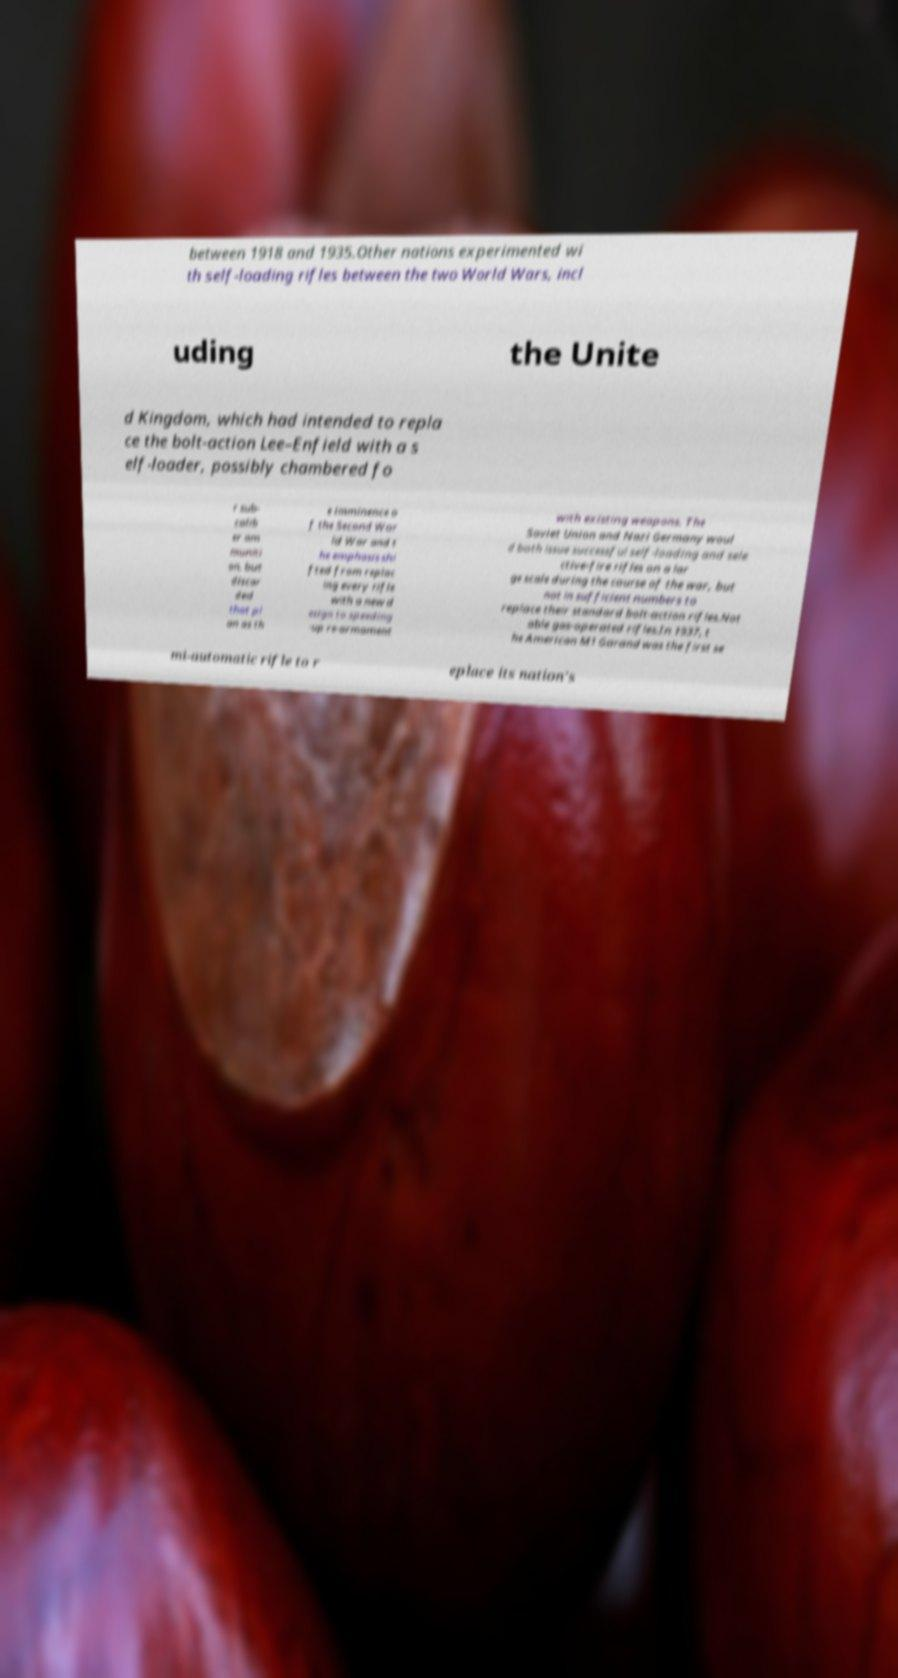Could you extract and type out the text from this image? between 1918 and 1935.Other nations experimented wi th self-loading rifles between the two World Wars, incl uding the Unite d Kingdom, which had intended to repla ce the bolt-action Lee–Enfield with a s elf-loader, possibly chambered fo r sub- calib er am muniti on, but discar ded that pl an as th e imminence o f the Second Wor ld War and t he emphasis shi fted from replac ing every rifle with a new d esign to speeding -up re-armament with existing weapons. The Soviet Union and Nazi Germany woul d both issue successful self-loading and sele ctive-fire rifles on a lar ge scale during the course of the war, but not in sufficient numbers to replace their standard bolt-action rifles.Not able gas-operated rifles.In 1937, t he American M1 Garand was the first se mi-automatic rifle to r eplace its nation's 